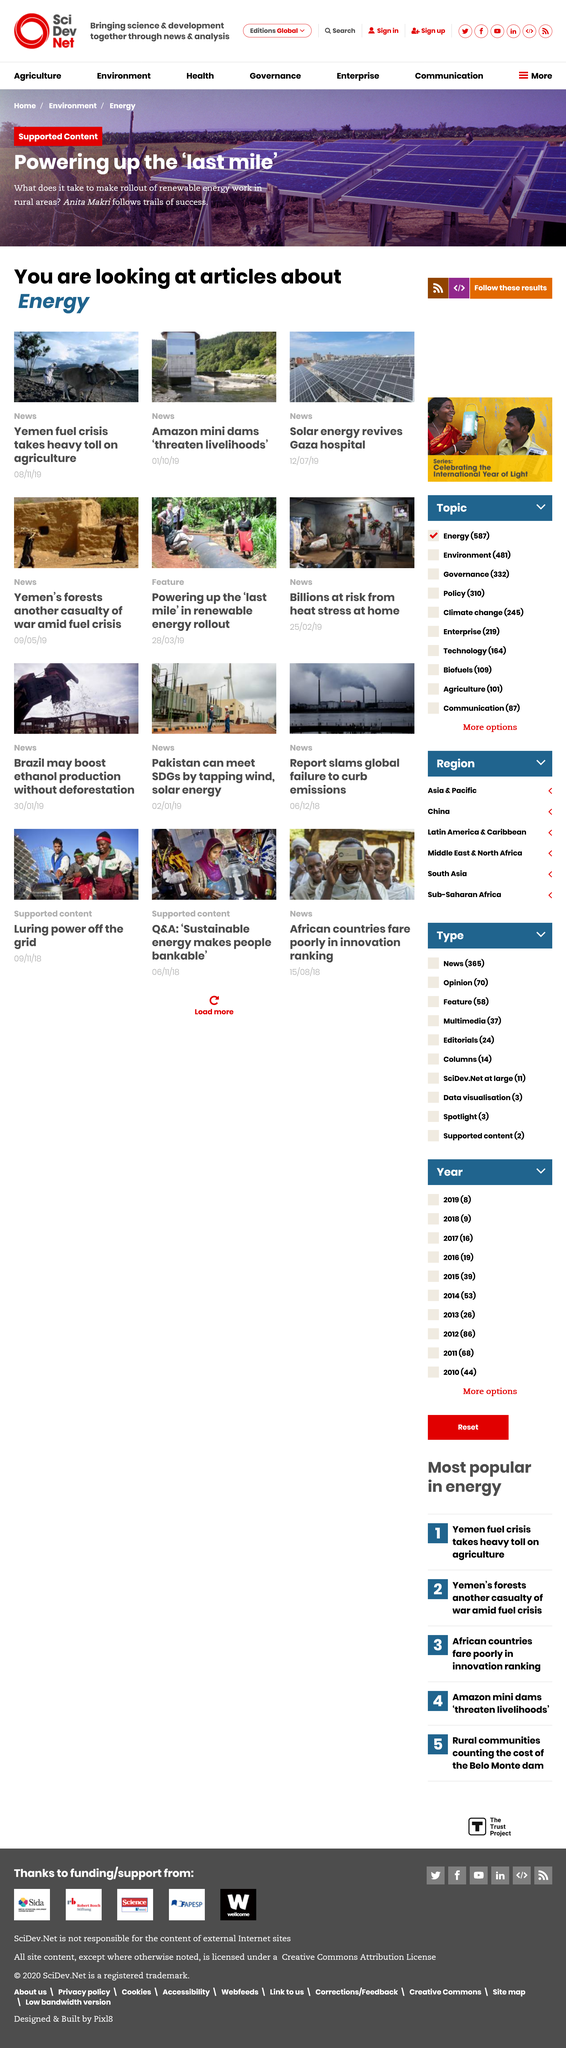List a handful of essential elements in this visual. The use of solar energy has revived a hospital in Gaza, providing it with a reliable source of power. The Amazon mini dams pose a significant threat to the livelihoods of those who depend on the river for their daily needs. The ongoing fuel crisis in Yemen is having a devastating impact on the country's agriculture sector, causing significant harm to crops and livestock. 